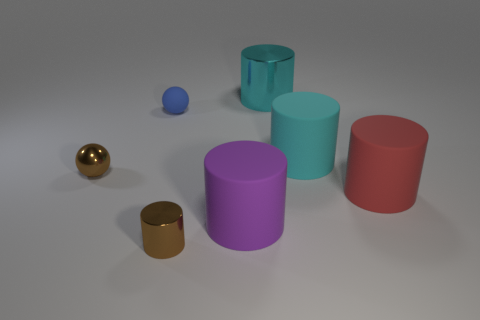Subtract all large cyan rubber cylinders. How many cylinders are left? 4 Add 3 tiny brown shiny cylinders. How many objects exist? 10 Subtract all blue spheres. How many spheres are left? 1 Subtract all balls. How many objects are left? 5 Subtract all cyan spheres. How many cyan cylinders are left? 2 Add 5 small gray things. How many small gray things exist? 5 Subtract 0 cyan spheres. How many objects are left? 7 Subtract 4 cylinders. How many cylinders are left? 1 Subtract all brown cylinders. Subtract all blue blocks. How many cylinders are left? 4 Subtract all rubber things. Subtract all blue matte balls. How many objects are left? 2 